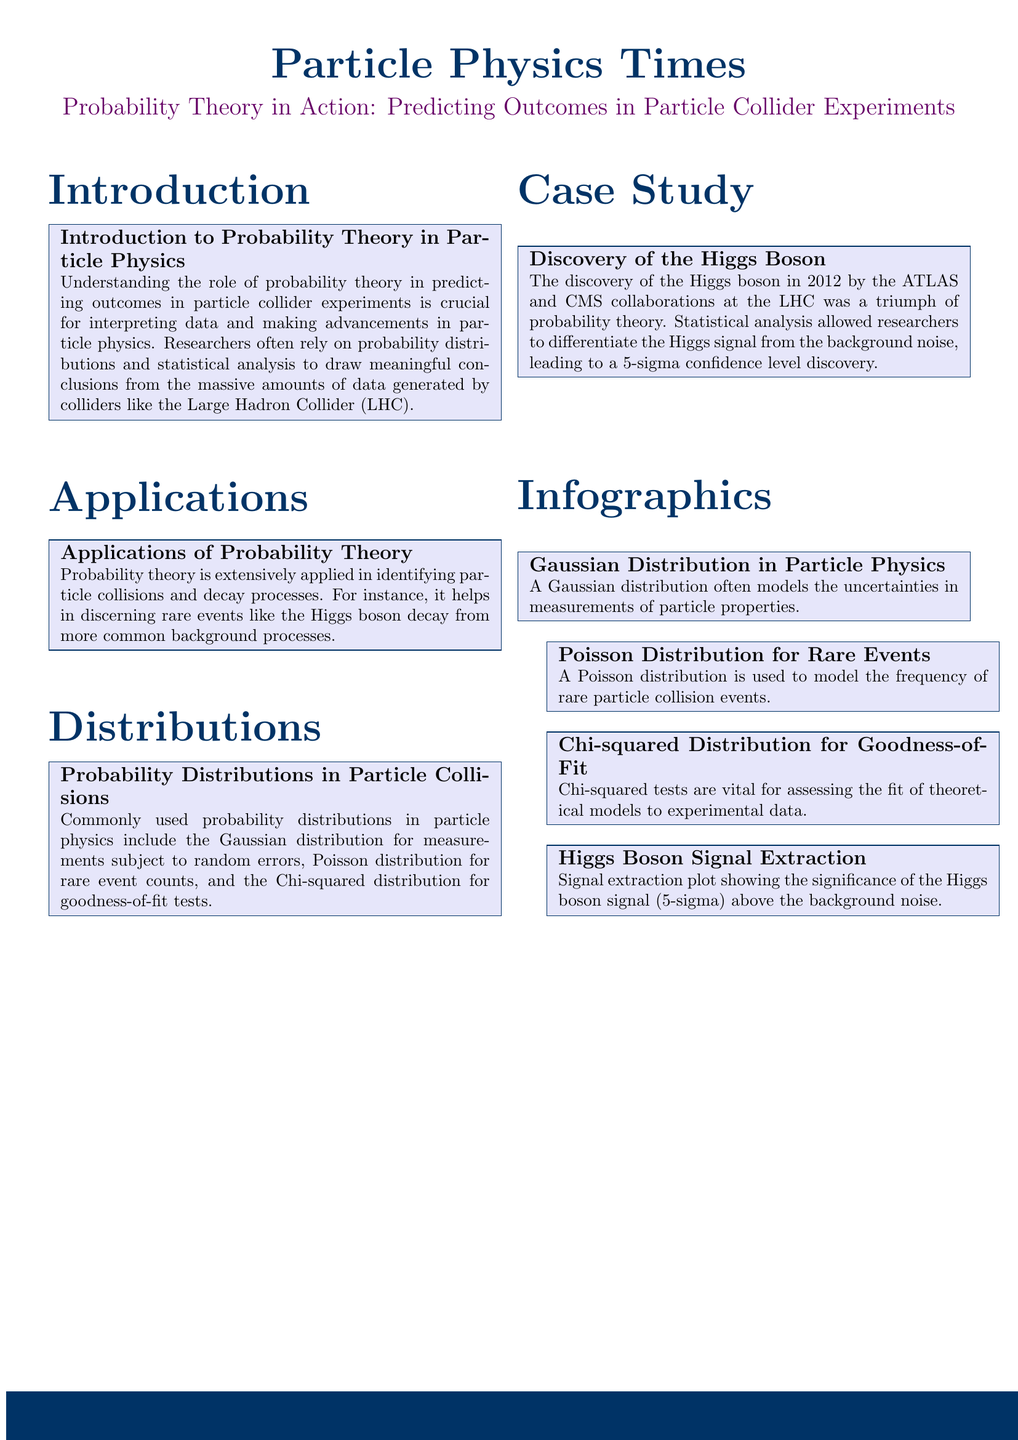What is the title of the document? The title of the document is indicated prominently at the top, which is "Probability Theory in Action: Predicting Outcomes in Particle Collider Experiments."
Answer: Probability Theory in Action: Predicting Outcomes in Particle Collider Experiments Which collaboration discovered the Higgs boson? The document mentions the ATLAS and CMS collaborations as the groups that discovered the Higgs boson.
Answer: ATLAS and CMS What statistical significance level was achieved for the Higgs boson discovery? The document states that the discovery was made with a 5-sigma confidence level.
Answer: 5-sigma What type of distribution is used for measuring particle properties? The Gaussian distribution is commonly used for modeling uncertainties in measurements of particle properties.
Answer: Gaussian distribution Which probability distribution is used for rare events in particle physics? The Poisson distribution is specifically mentioned in relation to modeling the frequency of rare particle collision events.
Answer: Poisson distribution What is the role of Chi-squared distribution in experimental data? The Chi-squared distribution is used for goodness-of-fit tests, which assess how well theoretical models fit experimental data.
Answer: Goodness-of-fit What major achievement does the case study highlight? The case study focuses on the discovery of the Higgs boson as a significant milestone in particle physics using probability theory.
Answer: Discovery of the Higgs boson What is the purpose of probability theory in particle collider experiments? Probability theory is crucial for interpreting data and making advancements in particle physics by analyzing vast amounts of collision data.
Answer: Interpreting data What visual representation is provided for the Higgs boson signal? The document includes a signal extraction plot showing the significance of the Higgs boson signal above background noise.
Answer: Signal extraction plot 